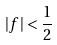Convert formula to latex. <formula><loc_0><loc_0><loc_500><loc_500>| f | < \frac { 1 } { 2 }</formula> 